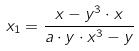Convert formula to latex. <formula><loc_0><loc_0><loc_500><loc_500>x _ { 1 } = \frac { x - y ^ { 3 } \cdot x } { a \cdot y \cdot x ^ { 3 } - y }</formula> 